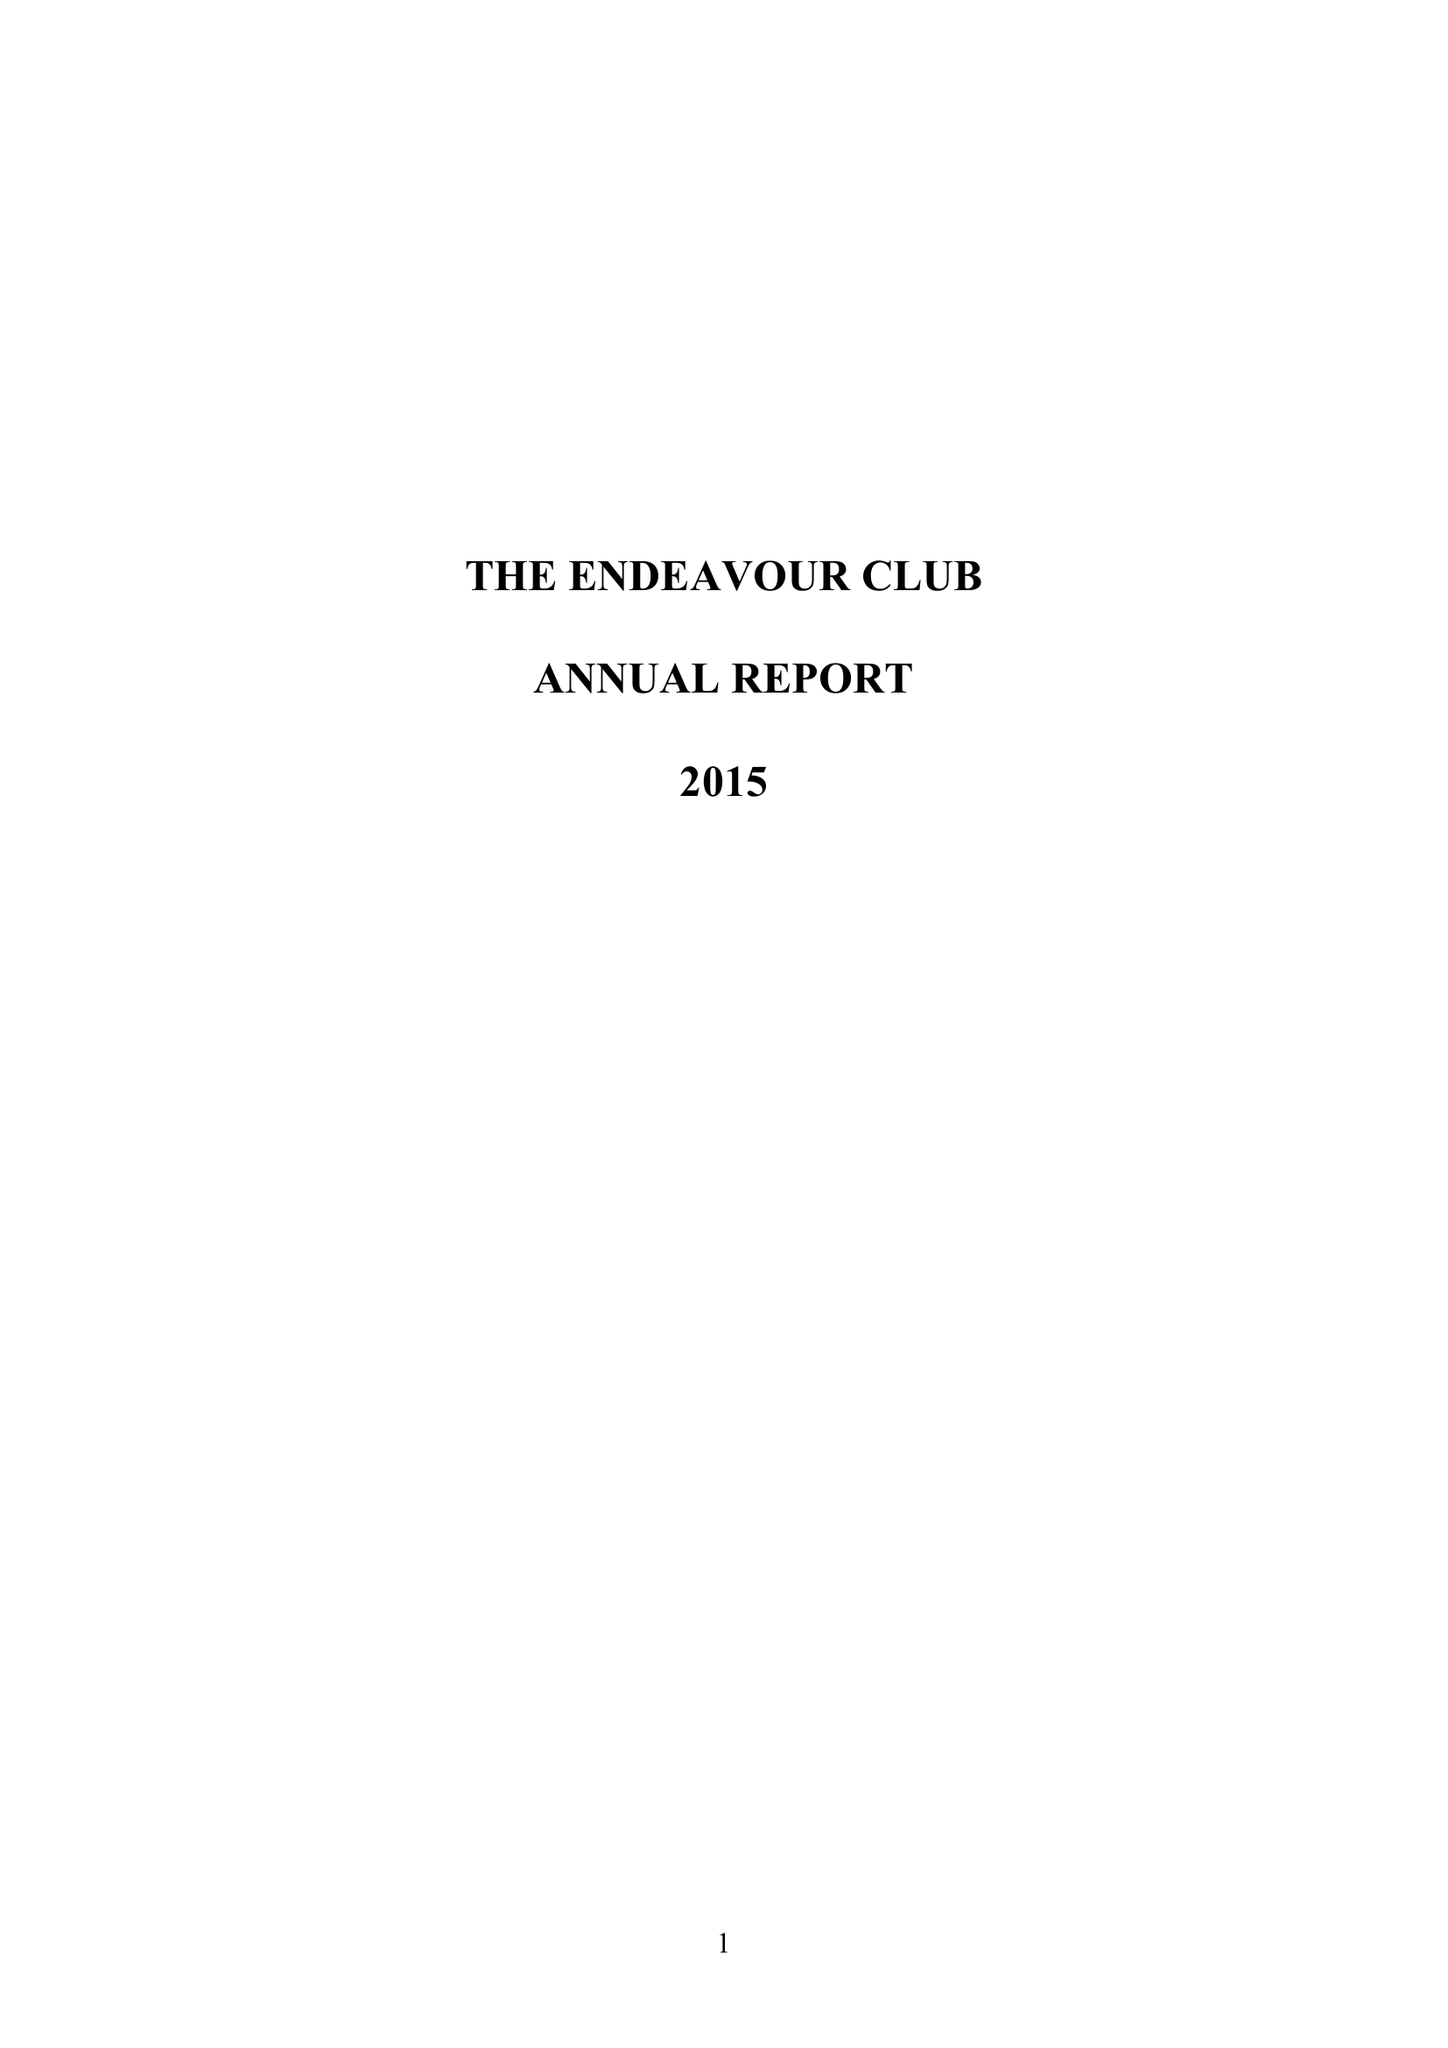What is the value for the income_annually_in_british_pounds?
Answer the question using a single word or phrase. 61000.00 